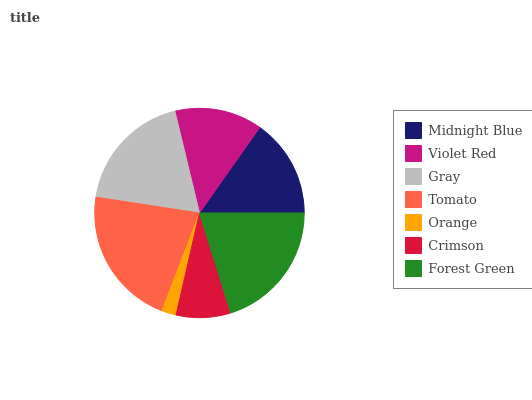Is Orange the minimum?
Answer yes or no. Yes. Is Tomato the maximum?
Answer yes or no. Yes. Is Violet Red the minimum?
Answer yes or no. No. Is Violet Red the maximum?
Answer yes or no. No. Is Midnight Blue greater than Violet Red?
Answer yes or no. Yes. Is Violet Red less than Midnight Blue?
Answer yes or no. Yes. Is Violet Red greater than Midnight Blue?
Answer yes or no. No. Is Midnight Blue less than Violet Red?
Answer yes or no. No. Is Midnight Blue the high median?
Answer yes or no. Yes. Is Midnight Blue the low median?
Answer yes or no. Yes. Is Tomato the high median?
Answer yes or no. No. Is Gray the low median?
Answer yes or no. No. 